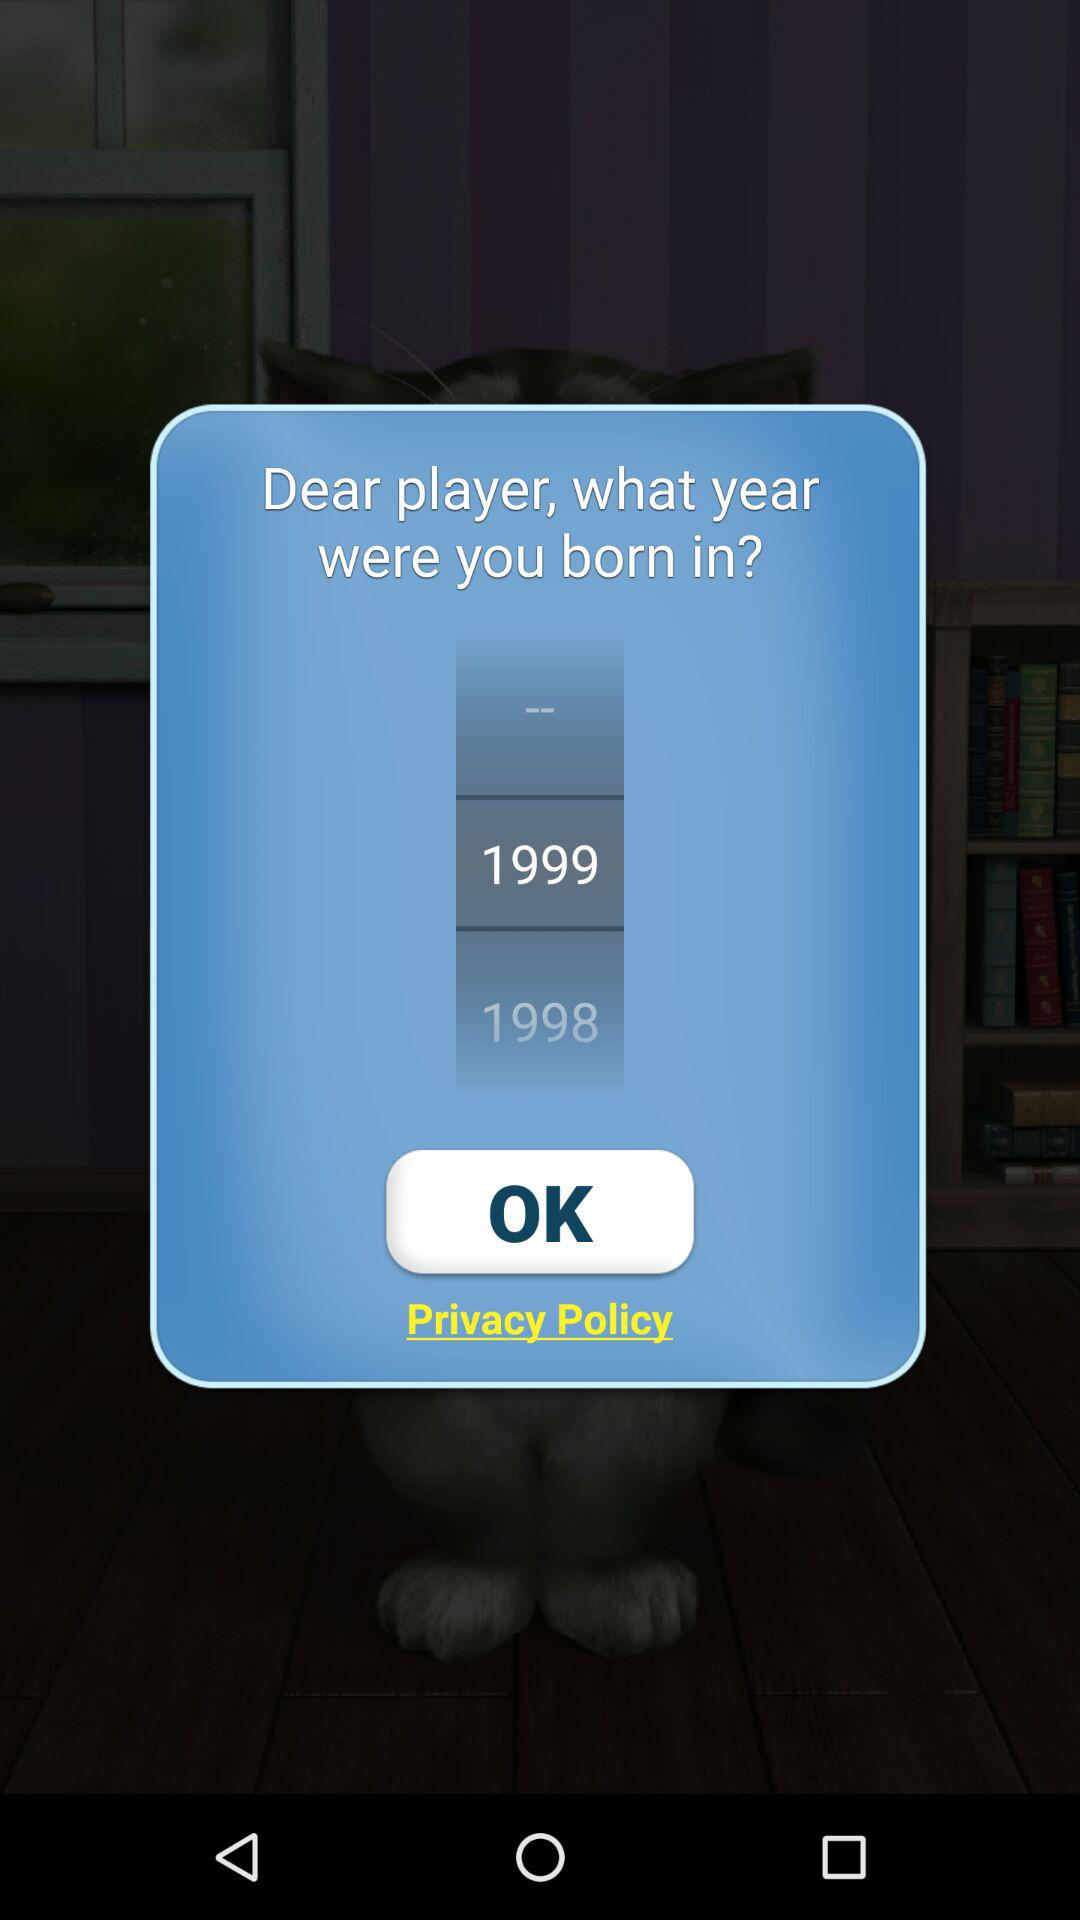Which year has been selected? The selected year is 1999. 